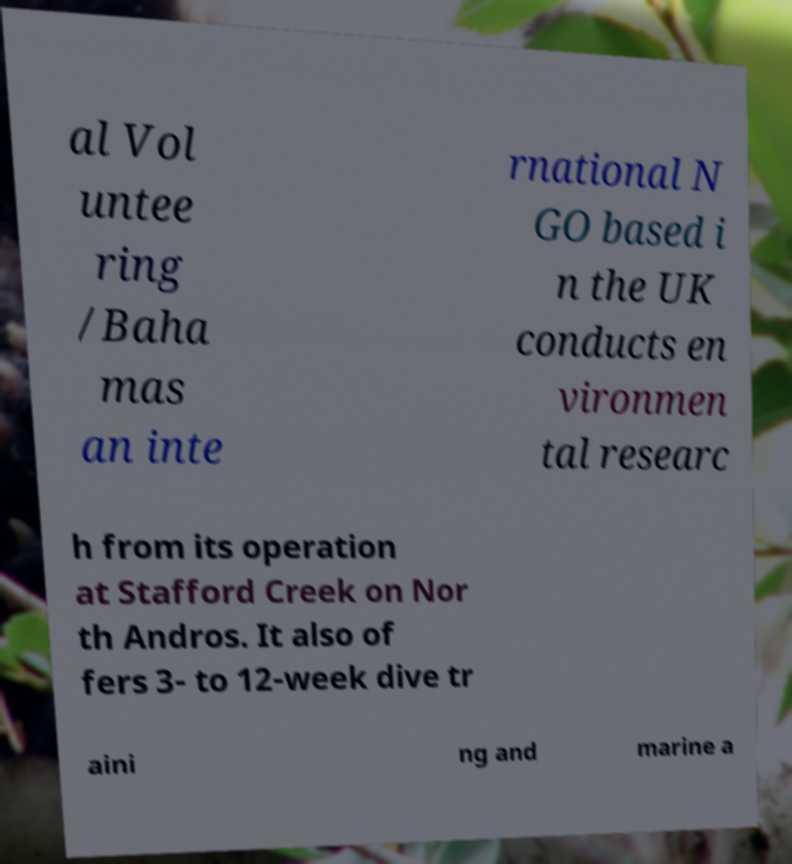What messages or text are displayed in this image? I need them in a readable, typed format. al Vol untee ring /Baha mas an inte rnational N GO based i n the UK conducts en vironmen tal researc h from its operation at Stafford Creek on Nor th Andros. It also of fers 3- to 12-week dive tr aini ng and marine a 